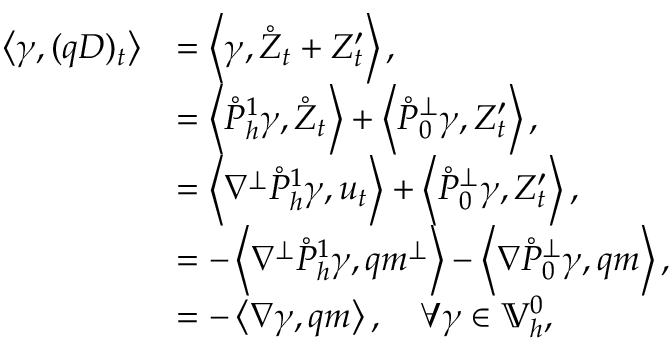Convert formula to latex. <formula><loc_0><loc_0><loc_500><loc_500>\begin{array} { r l } { \left \langle \gamma , ( q D ) _ { t } \right \rangle } & { = \left \langle \gamma , \mathring { Z } _ { t } + Z _ { t } ^ { \prime } \right \rangle , } \\ & { = \left \langle \mathring { P } _ { h } ^ { 1 } \gamma , \mathring { Z } _ { t } \right \rangle + \left \langle \mathring { P } _ { 0 } ^ { \perp } \gamma , Z _ { t } ^ { \prime } \right \rangle , } \\ & { = \left \langle \nabla ^ { \perp } \mathring { P } _ { h } ^ { 1 } \gamma , u _ { t } \right \rangle + \left \langle \mathring { P } _ { 0 } ^ { \perp } \gamma , Z _ { t } ^ { \prime } \right \rangle , } \\ & { = - \left \langle \nabla ^ { \perp } \mathring { P } _ { h } ^ { 1 } \gamma , q m ^ { \perp } \right \rangle - \left \langle \nabla \mathring { P } _ { 0 } ^ { \perp } \gamma , q m \right \rangle , } \\ & { = - \left \langle \nabla \gamma , q m \right \rangle , \quad \forall \gamma \in \mathbb { V } _ { h } ^ { 0 } , } \end{array}</formula> 